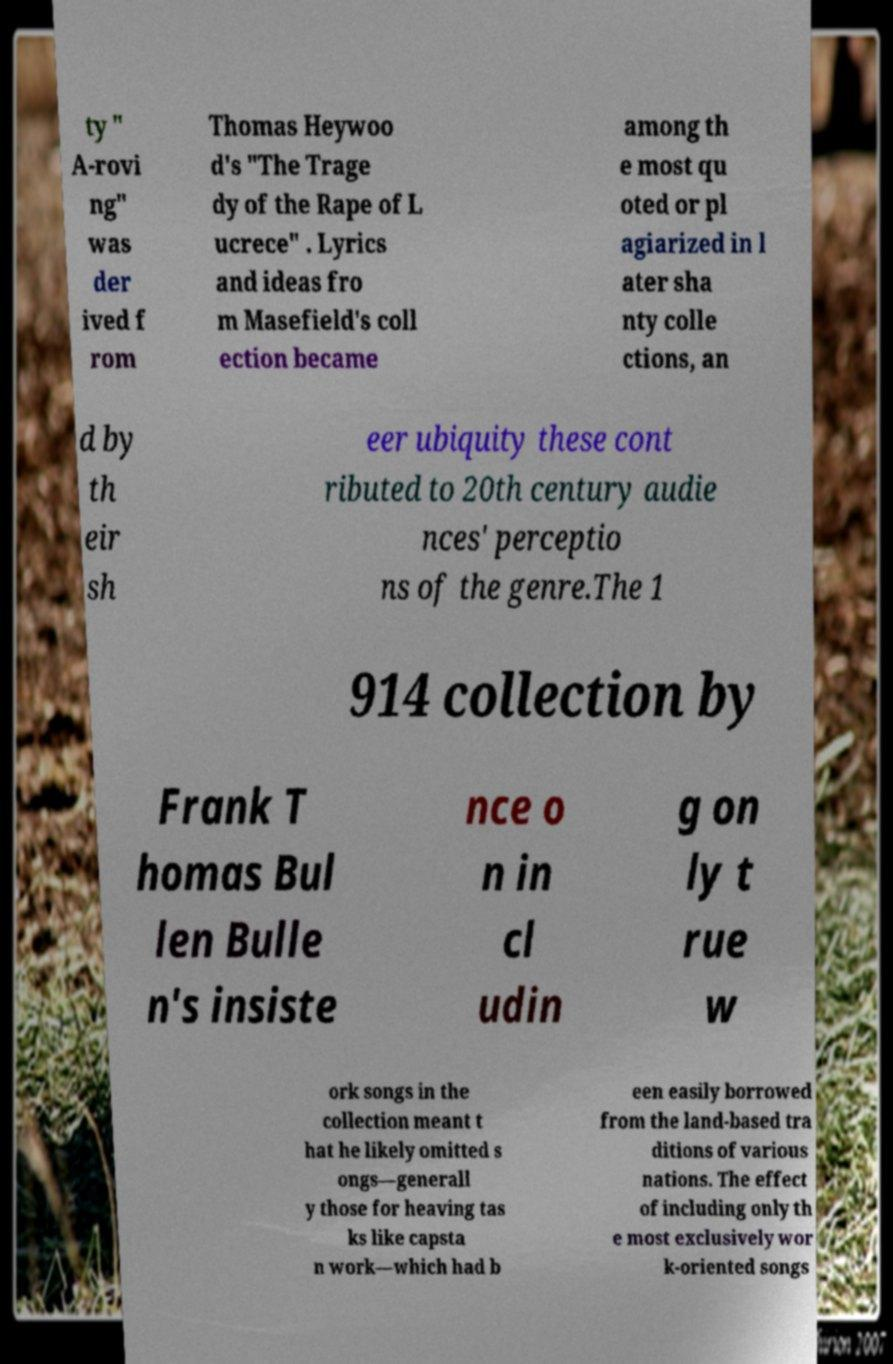Please read and relay the text visible in this image. What does it say? ty " A-rovi ng" was der ived f rom Thomas Heywoo d's "The Trage dy of the Rape of L ucrece" . Lyrics and ideas fro m Masefield's coll ection became among th e most qu oted or pl agiarized in l ater sha nty colle ctions, an d by th eir sh eer ubiquity these cont ributed to 20th century audie nces' perceptio ns of the genre.The 1 914 collection by Frank T homas Bul len Bulle n's insiste nce o n in cl udin g on ly t rue w ork songs in the collection meant t hat he likely omitted s ongs—generall y those for heaving tas ks like capsta n work—which had b een easily borrowed from the land-based tra ditions of various nations. The effect of including only th e most exclusively wor k-oriented songs 